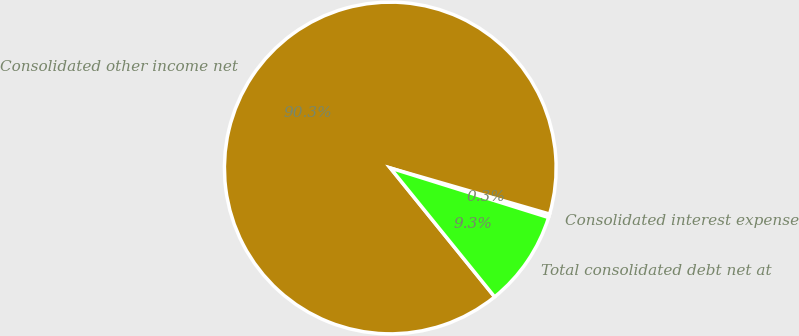<chart> <loc_0><loc_0><loc_500><loc_500><pie_chart><fcel>Consolidated interest expense<fcel>Consolidated other income net<fcel>Total consolidated debt net at<nl><fcel>0.35%<fcel>90.31%<fcel>9.34%<nl></chart> 